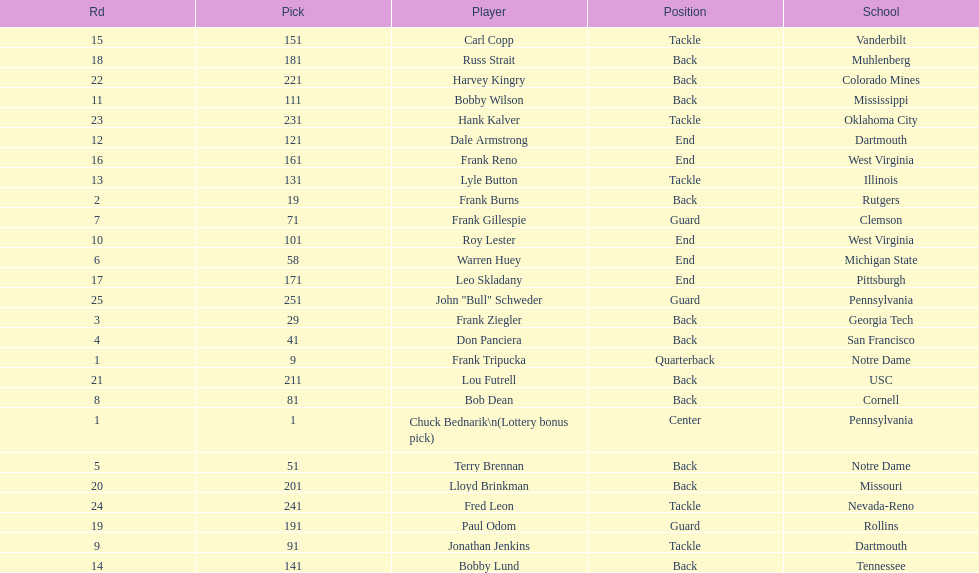What was the position that most of the players had? Back. Can you give me this table as a dict? {'header': ['Rd', 'Pick', 'Player', 'Position', 'School'], 'rows': [['15', '151', 'Carl Copp', 'Tackle', 'Vanderbilt'], ['18', '181', 'Russ Strait', 'Back', 'Muhlenberg'], ['22', '221', 'Harvey Kingry', 'Back', 'Colorado Mines'], ['11', '111', 'Bobby Wilson', 'Back', 'Mississippi'], ['23', '231', 'Hank Kalver', 'Tackle', 'Oklahoma City'], ['12', '121', 'Dale Armstrong', 'End', 'Dartmouth'], ['16', '161', 'Frank Reno', 'End', 'West Virginia'], ['13', '131', 'Lyle Button', 'Tackle', 'Illinois'], ['2', '19', 'Frank Burns', 'Back', 'Rutgers'], ['7', '71', 'Frank Gillespie', 'Guard', 'Clemson'], ['10', '101', 'Roy Lester', 'End', 'West Virginia'], ['6', '58', 'Warren Huey', 'End', 'Michigan State'], ['17', '171', 'Leo Skladany', 'End', 'Pittsburgh'], ['25', '251', 'John "Bull" Schweder', 'Guard', 'Pennsylvania'], ['3', '29', 'Frank Ziegler', 'Back', 'Georgia Tech'], ['4', '41', 'Don Panciera', 'Back', 'San Francisco'], ['1', '9', 'Frank Tripucka', 'Quarterback', 'Notre Dame'], ['21', '211', 'Lou Futrell', 'Back', 'USC'], ['8', '81', 'Bob Dean', 'Back', 'Cornell'], ['1', '1', 'Chuck Bednarik\\n(Lottery bonus pick)', 'Center', 'Pennsylvania'], ['5', '51', 'Terry Brennan', 'Back', 'Notre Dame'], ['20', '201', 'Lloyd Brinkman', 'Back', 'Missouri'], ['24', '241', 'Fred Leon', 'Tackle', 'Nevada-Reno'], ['19', '191', 'Paul Odom', 'Guard', 'Rollins'], ['9', '91', 'Jonathan Jenkins', 'Tackle', 'Dartmouth'], ['14', '141', 'Bobby Lund', 'Back', 'Tennessee']]} 